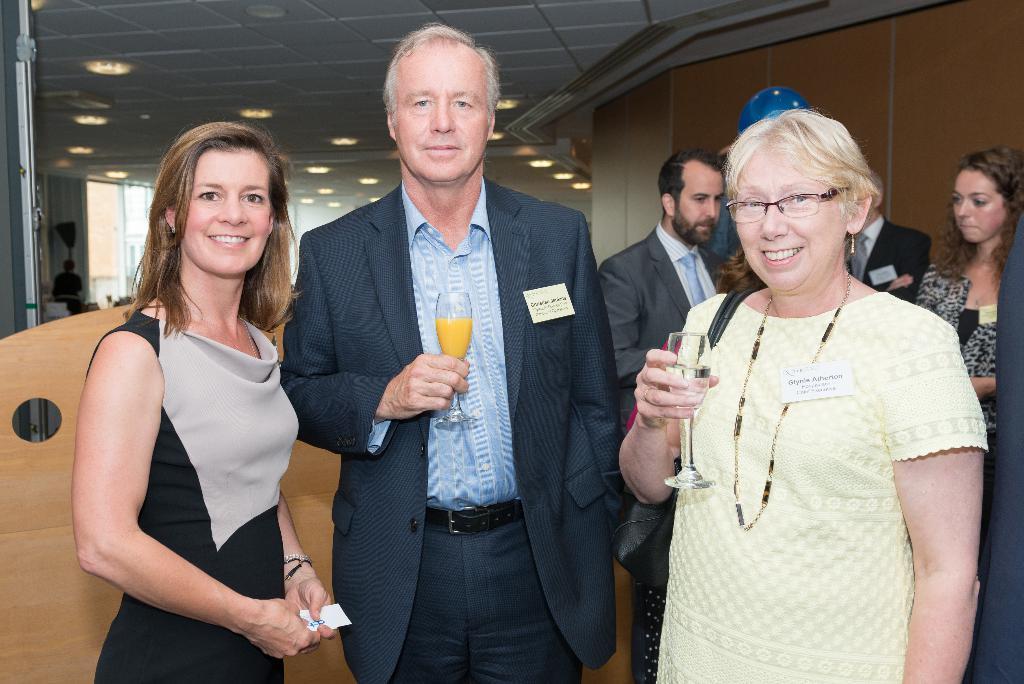Can you describe this image briefly? In this picture I can see there are some people standing here and there is a wall here in the backdrop and there are lights attached to the ceiling. 